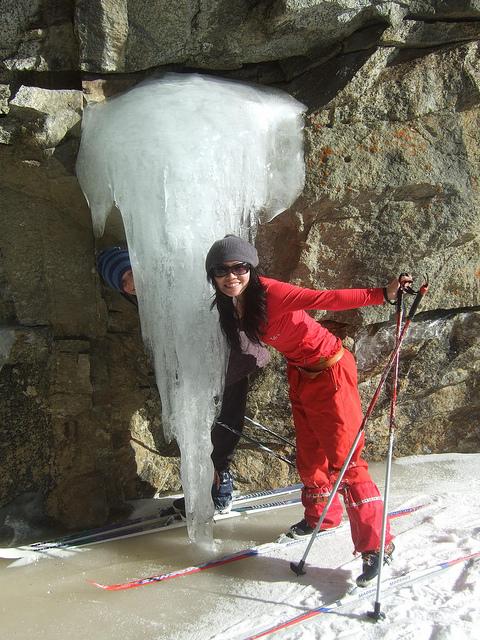What color is the ground?
Concise answer only. White. How many girls do you see?
Give a very brief answer. 2. What is the girl holding in her hand?
Concise answer only. Ski poles. 